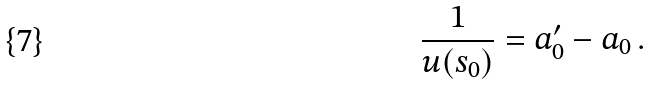Convert formula to latex. <formula><loc_0><loc_0><loc_500><loc_500>\frac { 1 } { u ( s _ { 0 } ) } & = a _ { 0 } ^ { \prime } - a _ { 0 } \, .</formula> 